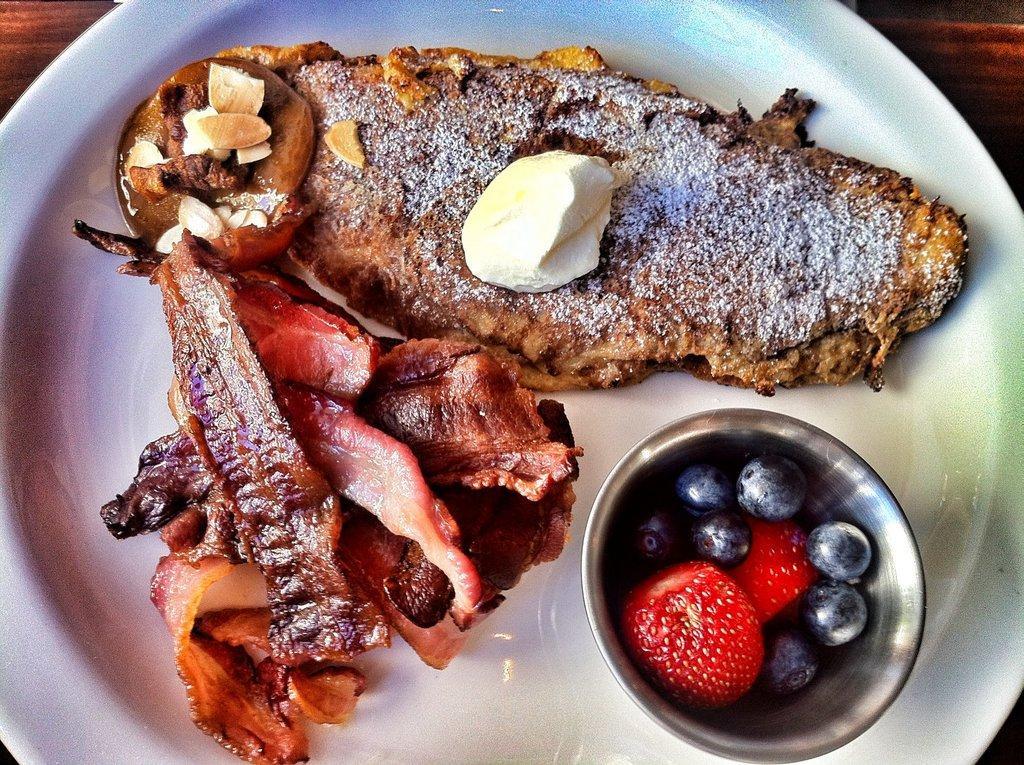Can you describe this image briefly? In this picture I can observe some food places in the white color plate. On the right side I can observe some fruits in the small bowl. This plate is placed on the brown color surface. 